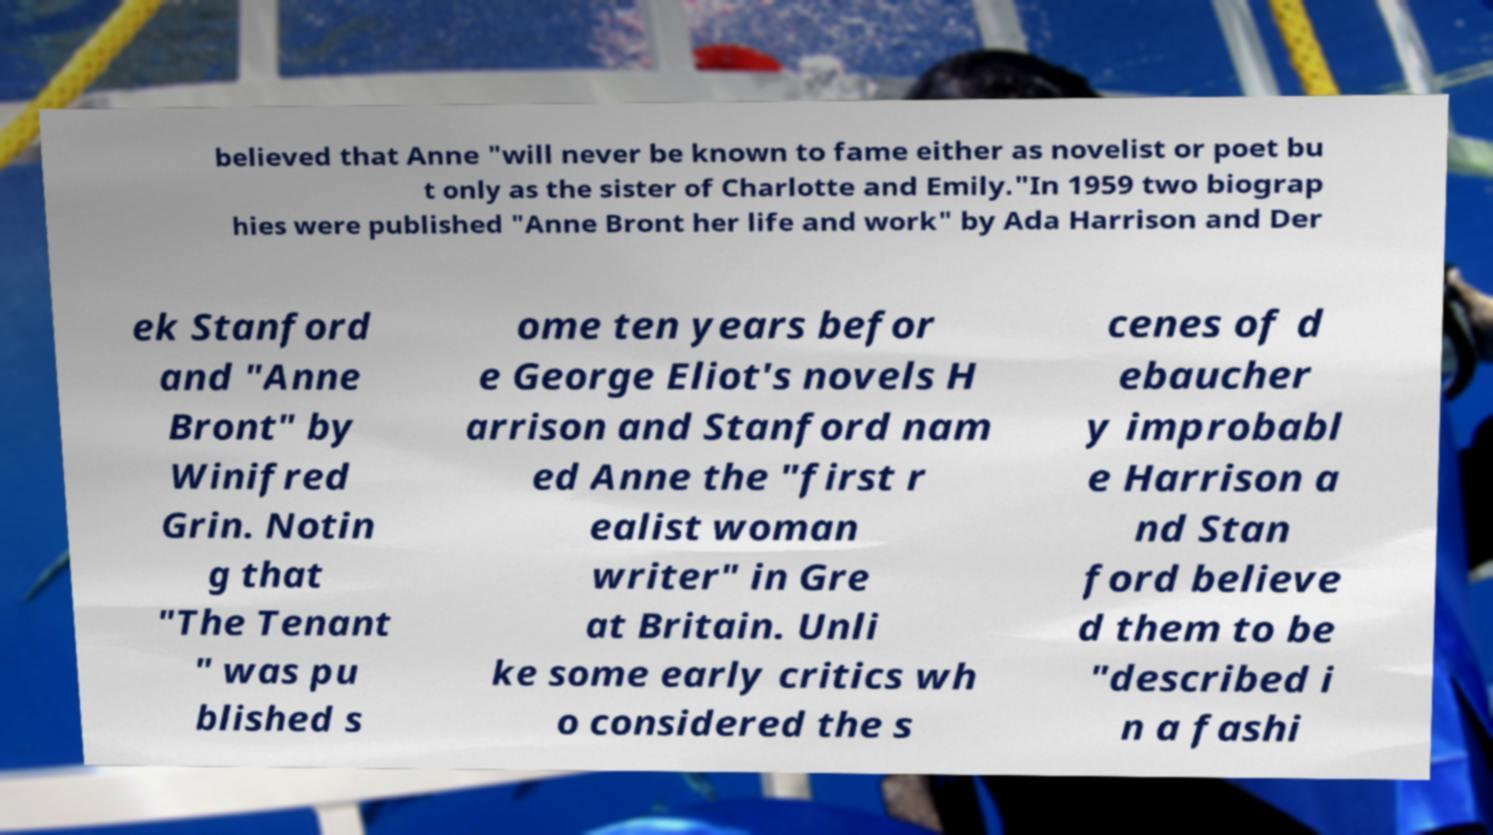Can you accurately transcribe the text from the provided image for me? believed that Anne "will never be known to fame either as novelist or poet bu t only as the sister of Charlotte and Emily."In 1959 two biograp hies were published "Anne Bront her life and work" by Ada Harrison and Der ek Stanford and "Anne Bront" by Winifred Grin. Notin g that "The Tenant " was pu blished s ome ten years befor e George Eliot's novels H arrison and Stanford nam ed Anne the "first r ealist woman writer" in Gre at Britain. Unli ke some early critics wh o considered the s cenes of d ebaucher y improbabl e Harrison a nd Stan ford believe d them to be "described i n a fashi 